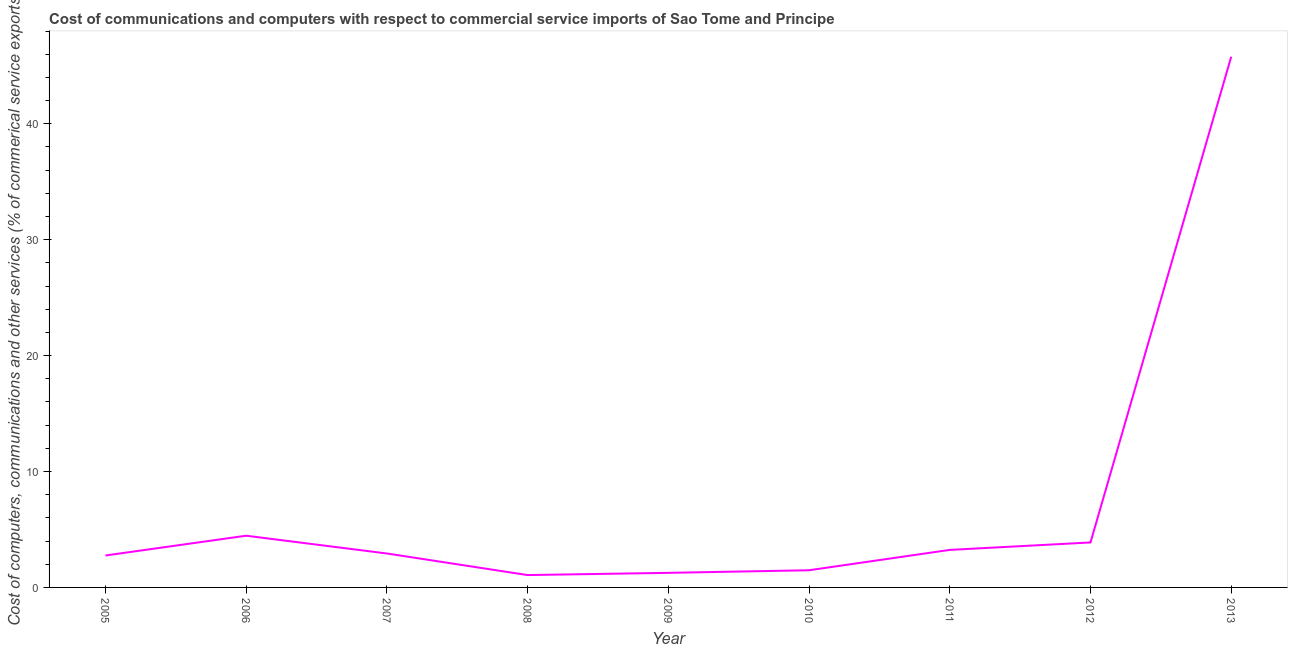What is the cost of communications in 2007?
Offer a very short reply. 2.93. Across all years, what is the maximum  computer and other services?
Your response must be concise. 45.78. Across all years, what is the minimum cost of communications?
Offer a terse response. 1.07. In which year was the cost of communications maximum?
Your answer should be compact. 2013. What is the sum of the cost of communications?
Your response must be concise. 66.85. What is the difference between the  computer and other services in 2010 and 2011?
Keep it short and to the point. -1.76. What is the average cost of communications per year?
Give a very brief answer. 7.43. What is the median cost of communications?
Provide a succinct answer. 2.93. Do a majority of the years between 2012 and 2007 (inclusive) have  computer and other services greater than 16 %?
Provide a short and direct response. Yes. What is the ratio of the cost of communications in 2007 to that in 2010?
Make the answer very short. 1.98. Is the cost of communications in 2008 less than that in 2011?
Ensure brevity in your answer.  Yes. What is the difference between the highest and the second highest  computer and other services?
Ensure brevity in your answer.  41.32. What is the difference between the highest and the lowest  computer and other services?
Your answer should be very brief. 44.71. Does the cost of communications monotonically increase over the years?
Give a very brief answer. No. How many lines are there?
Keep it short and to the point. 1. What is the difference between two consecutive major ticks on the Y-axis?
Make the answer very short. 10. Does the graph contain any zero values?
Provide a succinct answer. No. What is the title of the graph?
Your answer should be very brief. Cost of communications and computers with respect to commercial service imports of Sao Tome and Principe. What is the label or title of the X-axis?
Your response must be concise. Year. What is the label or title of the Y-axis?
Make the answer very short. Cost of computers, communications and other services (% of commerical service exports). What is the Cost of computers, communications and other services (% of commerical service exports) in 2005?
Keep it short and to the point. 2.76. What is the Cost of computers, communications and other services (% of commerical service exports) of 2006?
Your answer should be very brief. 4.46. What is the Cost of computers, communications and other services (% of commerical service exports) of 2007?
Offer a terse response. 2.93. What is the Cost of computers, communications and other services (% of commerical service exports) of 2008?
Your answer should be compact. 1.07. What is the Cost of computers, communications and other services (% of commerical service exports) in 2009?
Provide a short and direct response. 1.26. What is the Cost of computers, communications and other services (% of commerical service exports) in 2010?
Ensure brevity in your answer.  1.48. What is the Cost of computers, communications and other services (% of commerical service exports) of 2011?
Offer a terse response. 3.24. What is the Cost of computers, communications and other services (% of commerical service exports) of 2012?
Make the answer very short. 3.88. What is the Cost of computers, communications and other services (% of commerical service exports) of 2013?
Provide a succinct answer. 45.78. What is the difference between the Cost of computers, communications and other services (% of commerical service exports) in 2005 and 2006?
Provide a succinct answer. -1.71. What is the difference between the Cost of computers, communications and other services (% of commerical service exports) in 2005 and 2007?
Keep it short and to the point. -0.17. What is the difference between the Cost of computers, communications and other services (% of commerical service exports) in 2005 and 2008?
Make the answer very short. 1.69. What is the difference between the Cost of computers, communications and other services (% of commerical service exports) in 2005 and 2009?
Ensure brevity in your answer.  1.5. What is the difference between the Cost of computers, communications and other services (% of commerical service exports) in 2005 and 2010?
Provide a succinct answer. 1.27. What is the difference between the Cost of computers, communications and other services (% of commerical service exports) in 2005 and 2011?
Your answer should be compact. -0.48. What is the difference between the Cost of computers, communications and other services (% of commerical service exports) in 2005 and 2012?
Provide a succinct answer. -1.12. What is the difference between the Cost of computers, communications and other services (% of commerical service exports) in 2005 and 2013?
Provide a succinct answer. -43.02. What is the difference between the Cost of computers, communications and other services (% of commerical service exports) in 2006 and 2007?
Give a very brief answer. 1.53. What is the difference between the Cost of computers, communications and other services (% of commerical service exports) in 2006 and 2008?
Ensure brevity in your answer.  3.4. What is the difference between the Cost of computers, communications and other services (% of commerical service exports) in 2006 and 2009?
Offer a terse response. 3.2. What is the difference between the Cost of computers, communications and other services (% of commerical service exports) in 2006 and 2010?
Make the answer very short. 2.98. What is the difference between the Cost of computers, communications and other services (% of commerical service exports) in 2006 and 2011?
Your response must be concise. 1.22. What is the difference between the Cost of computers, communications and other services (% of commerical service exports) in 2006 and 2012?
Give a very brief answer. 0.58. What is the difference between the Cost of computers, communications and other services (% of commerical service exports) in 2006 and 2013?
Keep it short and to the point. -41.32. What is the difference between the Cost of computers, communications and other services (% of commerical service exports) in 2007 and 2008?
Offer a very short reply. 1.86. What is the difference between the Cost of computers, communications and other services (% of commerical service exports) in 2007 and 2009?
Your response must be concise. 1.67. What is the difference between the Cost of computers, communications and other services (% of commerical service exports) in 2007 and 2010?
Your answer should be compact. 1.45. What is the difference between the Cost of computers, communications and other services (% of commerical service exports) in 2007 and 2011?
Provide a short and direct response. -0.31. What is the difference between the Cost of computers, communications and other services (% of commerical service exports) in 2007 and 2012?
Offer a very short reply. -0.95. What is the difference between the Cost of computers, communications and other services (% of commerical service exports) in 2007 and 2013?
Make the answer very short. -42.85. What is the difference between the Cost of computers, communications and other services (% of commerical service exports) in 2008 and 2009?
Ensure brevity in your answer.  -0.19. What is the difference between the Cost of computers, communications and other services (% of commerical service exports) in 2008 and 2010?
Keep it short and to the point. -0.42. What is the difference between the Cost of computers, communications and other services (% of commerical service exports) in 2008 and 2011?
Make the answer very short. -2.17. What is the difference between the Cost of computers, communications and other services (% of commerical service exports) in 2008 and 2012?
Keep it short and to the point. -2.81. What is the difference between the Cost of computers, communications and other services (% of commerical service exports) in 2008 and 2013?
Make the answer very short. -44.71. What is the difference between the Cost of computers, communications and other services (% of commerical service exports) in 2009 and 2010?
Offer a very short reply. -0.22. What is the difference between the Cost of computers, communications and other services (% of commerical service exports) in 2009 and 2011?
Provide a short and direct response. -1.98. What is the difference between the Cost of computers, communications and other services (% of commerical service exports) in 2009 and 2012?
Offer a very short reply. -2.62. What is the difference between the Cost of computers, communications and other services (% of commerical service exports) in 2009 and 2013?
Provide a succinct answer. -44.52. What is the difference between the Cost of computers, communications and other services (% of commerical service exports) in 2010 and 2011?
Provide a short and direct response. -1.76. What is the difference between the Cost of computers, communications and other services (% of commerical service exports) in 2010 and 2012?
Offer a very short reply. -2.4. What is the difference between the Cost of computers, communications and other services (% of commerical service exports) in 2010 and 2013?
Provide a succinct answer. -44.3. What is the difference between the Cost of computers, communications and other services (% of commerical service exports) in 2011 and 2012?
Keep it short and to the point. -0.64. What is the difference between the Cost of computers, communications and other services (% of commerical service exports) in 2011 and 2013?
Offer a very short reply. -42.54. What is the difference between the Cost of computers, communications and other services (% of commerical service exports) in 2012 and 2013?
Offer a very short reply. -41.9. What is the ratio of the Cost of computers, communications and other services (% of commerical service exports) in 2005 to that in 2006?
Provide a succinct answer. 0.62. What is the ratio of the Cost of computers, communications and other services (% of commerical service exports) in 2005 to that in 2007?
Make the answer very short. 0.94. What is the ratio of the Cost of computers, communications and other services (% of commerical service exports) in 2005 to that in 2008?
Your answer should be compact. 2.58. What is the ratio of the Cost of computers, communications and other services (% of commerical service exports) in 2005 to that in 2009?
Offer a terse response. 2.19. What is the ratio of the Cost of computers, communications and other services (% of commerical service exports) in 2005 to that in 2010?
Your response must be concise. 1.86. What is the ratio of the Cost of computers, communications and other services (% of commerical service exports) in 2005 to that in 2011?
Ensure brevity in your answer.  0.85. What is the ratio of the Cost of computers, communications and other services (% of commerical service exports) in 2005 to that in 2012?
Give a very brief answer. 0.71. What is the ratio of the Cost of computers, communications and other services (% of commerical service exports) in 2005 to that in 2013?
Offer a very short reply. 0.06. What is the ratio of the Cost of computers, communications and other services (% of commerical service exports) in 2006 to that in 2007?
Provide a short and direct response. 1.52. What is the ratio of the Cost of computers, communications and other services (% of commerical service exports) in 2006 to that in 2008?
Ensure brevity in your answer.  4.18. What is the ratio of the Cost of computers, communications and other services (% of commerical service exports) in 2006 to that in 2009?
Your response must be concise. 3.55. What is the ratio of the Cost of computers, communications and other services (% of commerical service exports) in 2006 to that in 2010?
Offer a terse response. 3.01. What is the ratio of the Cost of computers, communications and other services (% of commerical service exports) in 2006 to that in 2011?
Your answer should be very brief. 1.38. What is the ratio of the Cost of computers, communications and other services (% of commerical service exports) in 2006 to that in 2012?
Provide a short and direct response. 1.15. What is the ratio of the Cost of computers, communications and other services (% of commerical service exports) in 2006 to that in 2013?
Provide a succinct answer. 0.1. What is the ratio of the Cost of computers, communications and other services (% of commerical service exports) in 2007 to that in 2008?
Your answer should be very brief. 2.75. What is the ratio of the Cost of computers, communications and other services (% of commerical service exports) in 2007 to that in 2009?
Keep it short and to the point. 2.33. What is the ratio of the Cost of computers, communications and other services (% of commerical service exports) in 2007 to that in 2010?
Keep it short and to the point. 1.98. What is the ratio of the Cost of computers, communications and other services (% of commerical service exports) in 2007 to that in 2011?
Offer a very short reply. 0.9. What is the ratio of the Cost of computers, communications and other services (% of commerical service exports) in 2007 to that in 2012?
Offer a terse response. 0.76. What is the ratio of the Cost of computers, communications and other services (% of commerical service exports) in 2007 to that in 2013?
Offer a terse response. 0.06. What is the ratio of the Cost of computers, communications and other services (% of commerical service exports) in 2008 to that in 2009?
Offer a terse response. 0.85. What is the ratio of the Cost of computers, communications and other services (% of commerical service exports) in 2008 to that in 2010?
Ensure brevity in your answer.  0.72. What is the ratio of the Cost of computers, communications and other services (% of commerical service exports) in 2008 to that in 2011?
Your answer should be very brief. 0.33. What is the ratio of the Cost of computers, communications and other services (% of commerical service exports) in 2008 to that in 2012?
Ensure brevity in your answer.  0.28. What is the ratio of the Cost of computers, communications and other services (% of commerical service exports) in 2008 to that in 2013?
Your answer should be very brief. 0.02. What is the ratio of the Cost of computers, communications and other services (% of commerical service exports) in 2009 to that in 2010?
Offer a very short reply. 0.85. What is the ratio of the Cost of computers, communications and other services (% of commerical service exports) in 2009 to that in 2011?
Keep it short and to the point. 0.39. What is the ratio of the Cost of computers, communications and other services (% of commerical service exports) in 2009 to that in 2012?
Ensure brevity in your answer.  0.32. What is the ratio of the Cost of computers, communications and other services (% of commerical service exports) in 2009 to that in 2013?
Your answer should be very brief. 0.03. What is the ratio of the Cost of computers, communications and other services (% of commerical service exports) in 2010 to that in 2011?
Ensure brevity in your answer.  0.46. What is the ratio of the Cost of computers, communications and other services (% of commerical service exports) in 2010 to that in 2012?
Your answer should be compact. 0.38. What is the ratio of the Cost of computers, communications and other services (% of commerical service exports) in 2010 to that in 2013?
Make the answer very short. 0.03. What is the ratio of the Cost of computers, communications and other services (% of commerical service exports) in 2011 to that in 2012?
Make the answer very short. 0.83. What is the ratio of the Cost of computers, communications and other services (% of commerical service exports) in 2011 to that in 2013?
Keep it short and to the point. 0.07. What is the ratio of the Cost of computers, communications and other services (% of commerical service exports) in 2012 to that in 2013?
Give a very brief answer. 0.09. 